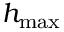<formula> <loc_0><loc_0><loc_500><loc_500>h _ { \max }</formula> 